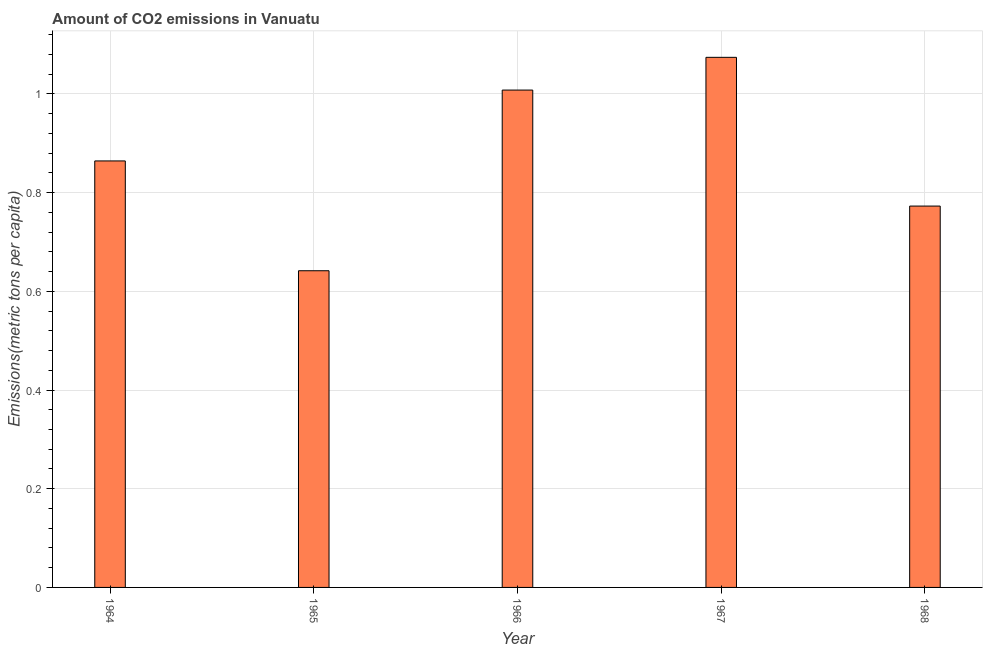Does the graph contain any zero values?
Your response must be concise. No. Does the graph contain grids?
Your response must be concise. Yes. What is the title of the graph?
Offer a terse response. Amount of CO2 emissions in Vanuatu. What is the label or title of the Y-axis?
Offer a terse response. Emissions(metric tons per capita). What is the amount of co2 emissions in 1965?
Keep it short and to the point. 0.64. Across all years, what is the maximum amount of co2 emissions?
Your answer should be compact. 1.07. Across all years, what is the minimum amount of co2 emissions?
Provide a succinct answer. 0.64. In which year was the amount of co2 emissions maximum?
Provide a short and direct response. 1967. In which year was the amount of co2 emissions minimum?
Provide a short and direct response. 1965. What is the sum of the amount of co2 emissions?
Your response must be concise. 4.36. What is the difference between the amount of co2 emissions in 1966 and 1967?
Provide a short and direct response. -0.07. What is the average amount of co2 emissions per year?
Your response must be concise. 0.87. What is the median amount of co2 emissions?
Provide a succinct answer. 0.86. In how many years, is the amount of co2 emissions greater than 0.4 metric tons per capita?
Your answer should be compact. 5. What is the ratio of the amount of co2 emissions in 1964 to that in 1968?
Your response must be concise. 1.12. Is the amount of co2 emissions in 1964 less than that in 1965?
Ensure brevity in your answer.  No. Is the difference between the amount of co2 emissions in 1965 and 1967 greater than the difference between any two years?
Give a very brief answer. Yes. What is the difference between the highest and the second highest amount of co2 emissions?
Your answer should be compact. 0.07. Is the sum of the amount of co2 emissions in 1966 and 1967 greater than the maximum amount of co2 emissions across all years?
Provide a succinct answer. Yes. What is the difference between the highest and the lowest amount of co2 emissions?
Ensure brevity in your answer.  0.43. How many bars are there?
Provide a short and direct response. 5. What is the Emissions(metric tons per capita) in 1964?
Offer a very short reply. 0.86. What is the Emissions(metric tons per capita) of 1965?
Offer a very short reply. 0.64. What is the Emissions(metric tons per capita) of 1966?
Your response must be concise. 1.01. What is the Emissions(metric tons per capita) in 1967?
Offer a very short reply. 1.07. What is the Emissions(metric tons per capita) of 1968?
Provide a short and direct response. 0.77. What is the difference between the Emissions(metric tons per capita) in 1964 and 1965?
Keep it short and to the point. 0.22. What is the difference between the Emissions(metric tons per capita) in 1964 and 1966?
Offer a terse response. -0.14. What is the difference between the Emissions(metric tons per capita) in 1964 and 1967?
Your answer should be compact. -0.21. What is the difference between the Emissions(metric tons per capita) in 1964 and 1968?
Make the answer very short. 0.09. What is the difference between the Emissions(metric tons per capita) in 1965 and 1966?
Your answer should be compact. -0.37. What is the difference between the Emissions(metric tons per capita) in 1965 and 1967?
Your response must be concise. -0.43. What is the difference between the Emissions(metric tons per capita) in 1965 and 1968?
Provide a succinct answer. -0.13. What is the difference between the Emissions(metric tons per capita) in 1966 and 1967?
Your answer should be very brief. -0.07. What is the difference between the Emissions(metric tons per capita) in 1966 and 1968?
Provide a succinct answer. 0.24. What is the difference between the Emissions(metric tons per capita) in 1967 and 1968?
Offer a very short reply. 0.3. What is the ratio of the Emissions(metric tons per capita) in 1964 to that in 1965?
Give a very brief answer. 1.35. What is the ratio of the Emissions(metric tons per capita) in 1964 to that in 1966?
Offer a very short reply. 0.86. What is the ratio of the Emissions(metric tons per capita) in 1964 to that in 1967?
Keep it short and to the point. 0.81. What is the ratio of the Emissions(metric tons per capita) in 1964 to that in 1968?
Your answer should be compact. 1.12. What is the ratio of the Emissions(metric tons per capita) in 1965 to that in 1966?
Your answer should be compact. 0.64. What is the ratio of the Emissions(metric tons per capita) in 1965 to that in 1967?
Offer a very short reply. 0.6. What is the ratio of the Emissions(metric tons per capita) in 1965 to that in 1968?
Ensure brevity in your answer.  0.83. What is the ratio of the Emissions(metric tons per capita) in 1966 to that in 1967?
Offer a terse response. 0.94. What is the ratio of the Emissions(metric tons per capita) in 1966 to that in 1968?
Make the answer very short. 1.3. What is the ratio of the Emissions(metric tons per capita) in 1967 to that in 1968?
Make the answer very short. 1.39. 